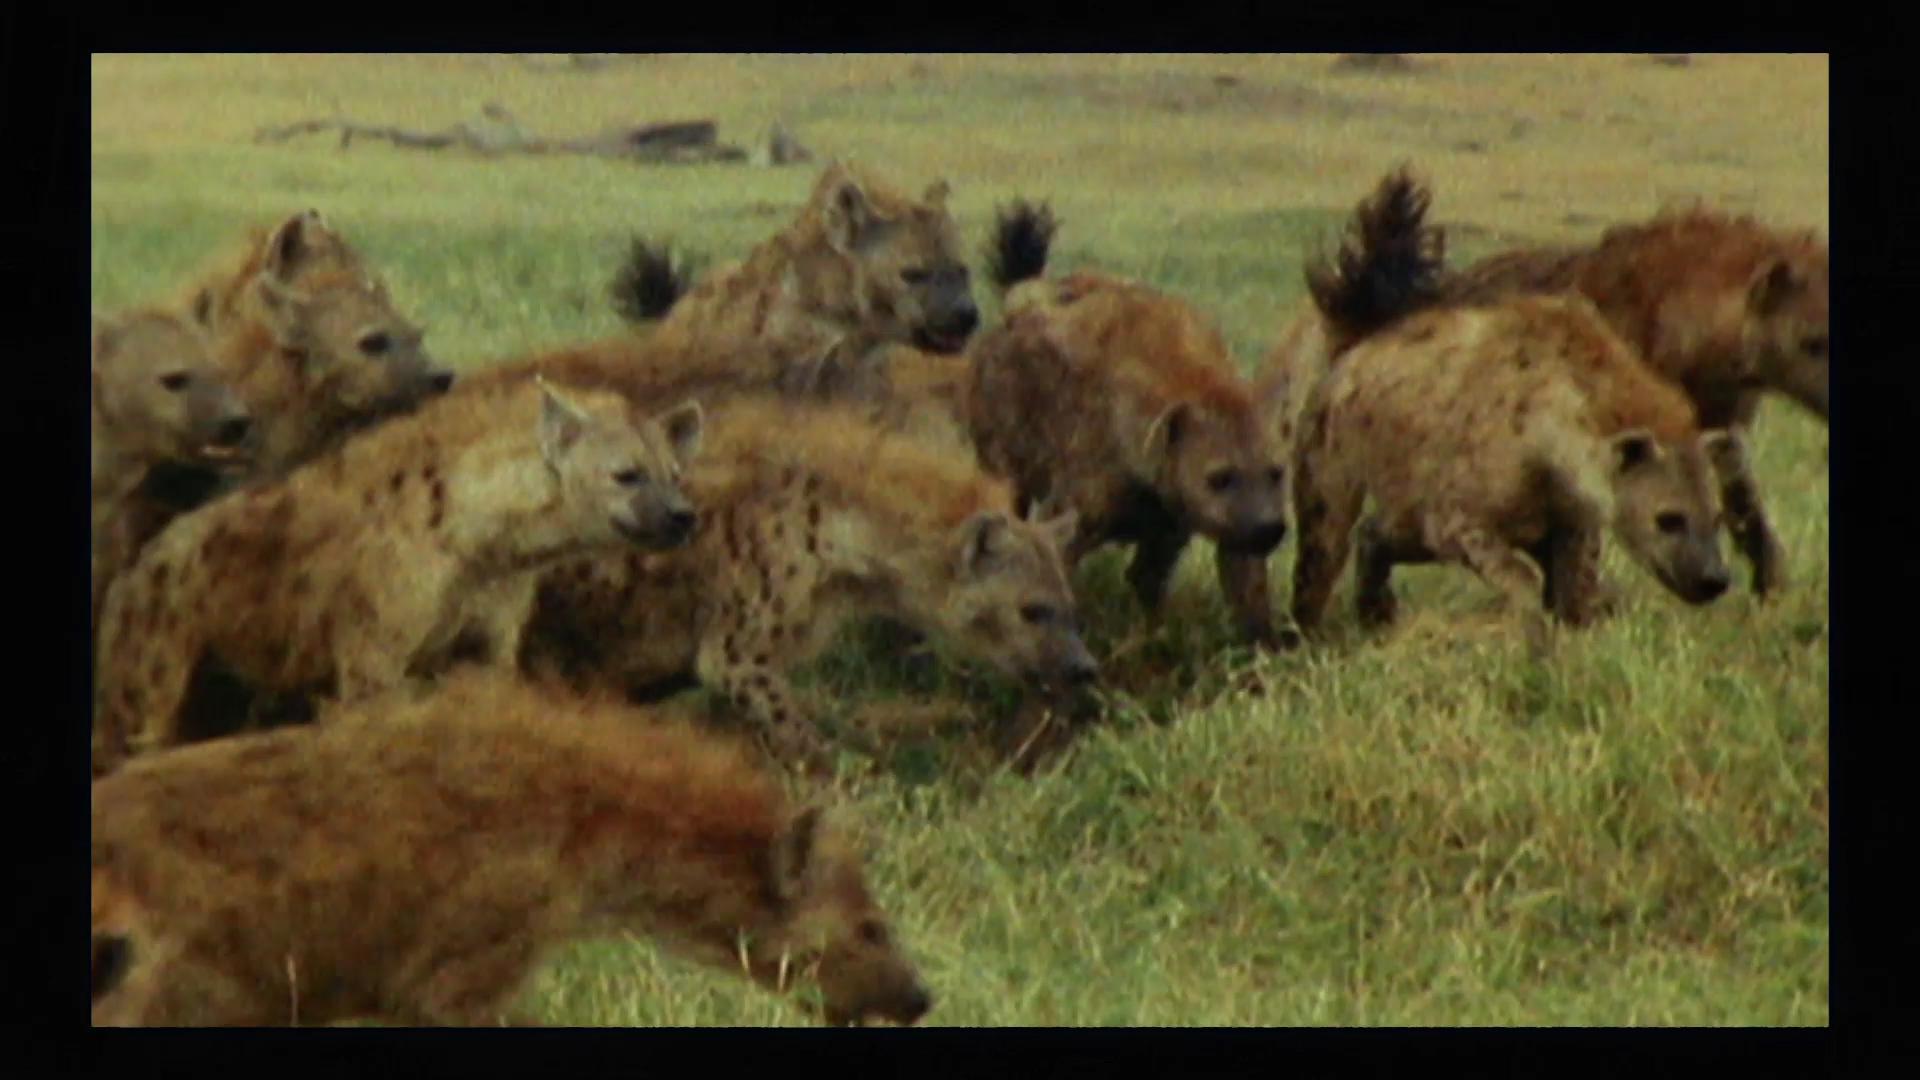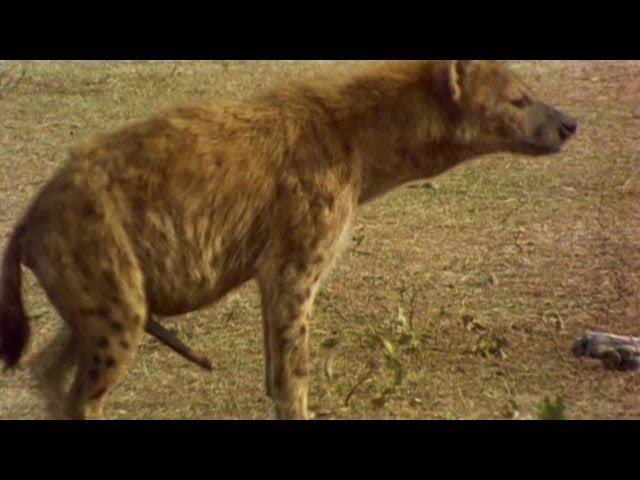The first image is the image on the left, the second image is the image on the right. Examine the images to the left and right. Is the description "The right image contains no more than three hyenas." accurate? Answer yes or no. Yes. The first image is the image on the left, the second image is the image on the right. Analyze the images presented: Is the assertion "A male lion is being attacked by hyenas." valid? Answer yes or no. No. 